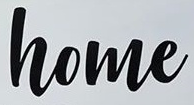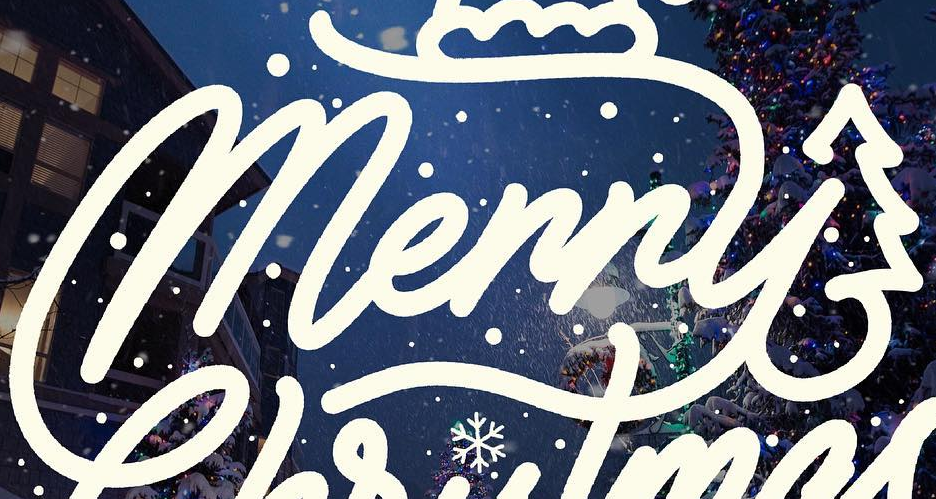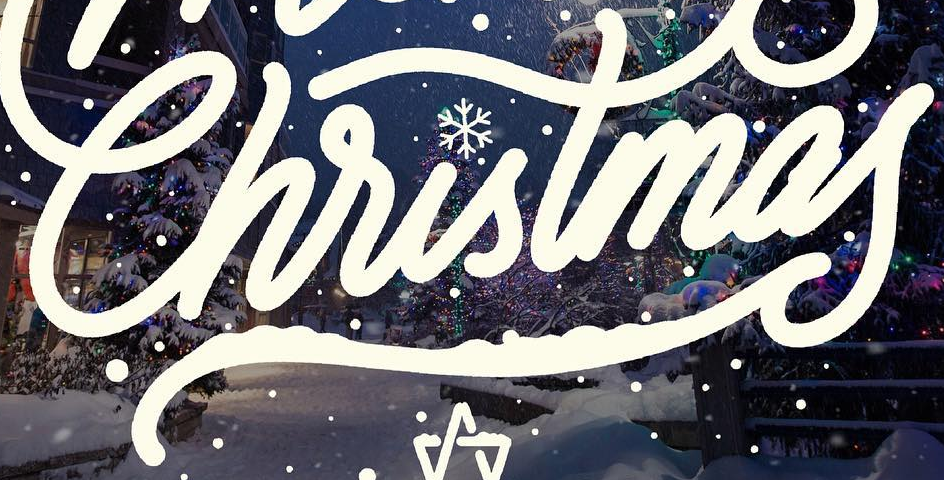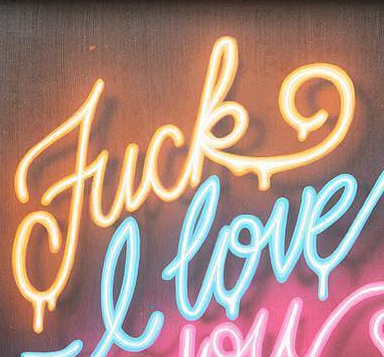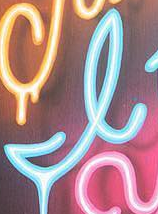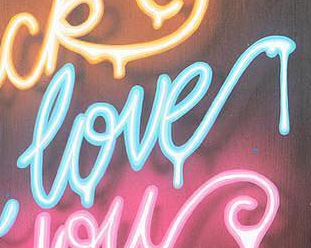What words are shown in these images in order, separated by a semicolon? home; Merry; Christmas; Fuck; I; love 